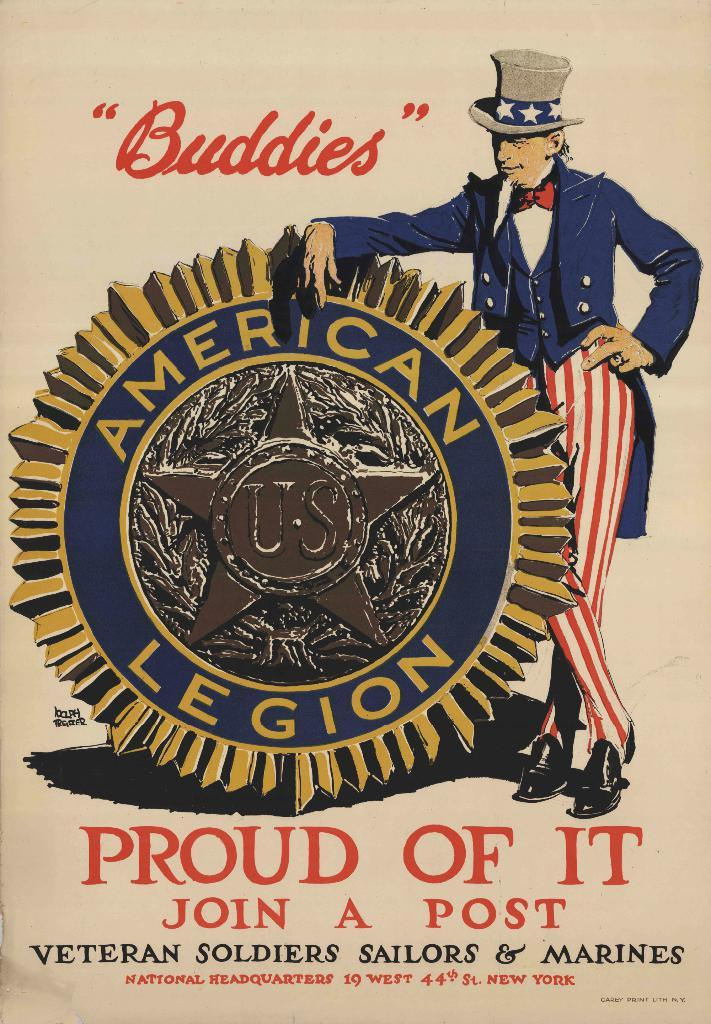<image>
Summarize the visual content of the image. An old ad for the American Legion saying to join a post. 